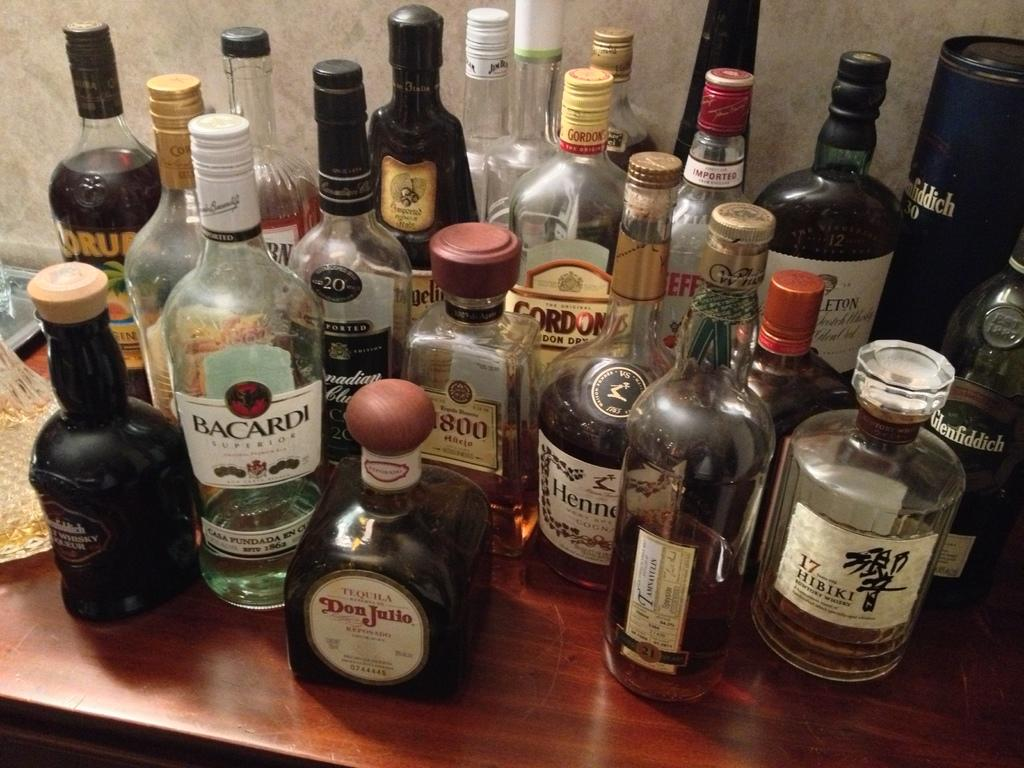<image>
Give a short and clear explanation of the subsequent image. a lot of liquor bottles, with a bottle of Barcardi near the front left. 